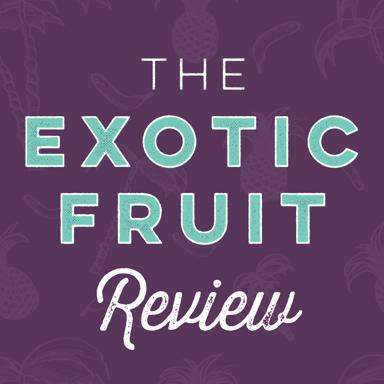What kind of articles or content could this image be associated with? This image could be associated with a variety of content including detailed reviews of different exotic fruits, recipes that use these fruits, health benefits of exotic fruits, and cultural significance of fruits like pineapples in different regions. 